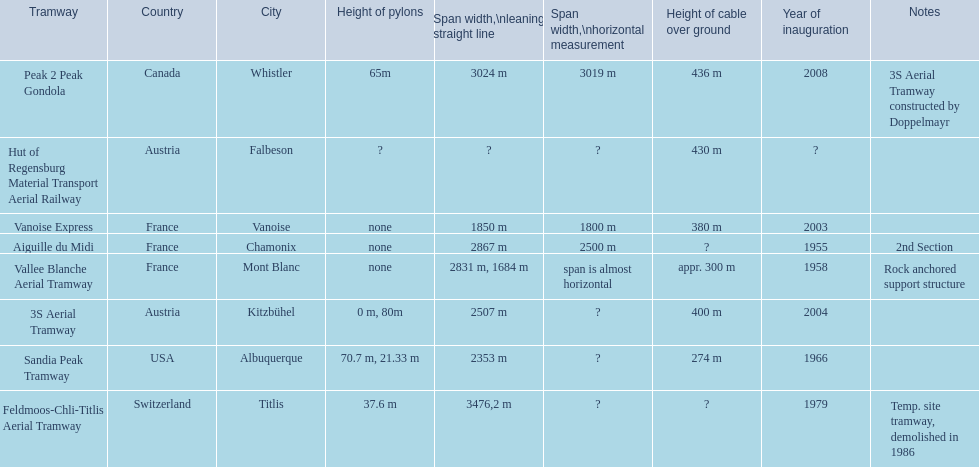How much longer is the peak 2 peak gondola than the 32 aerial tramway? 517. 